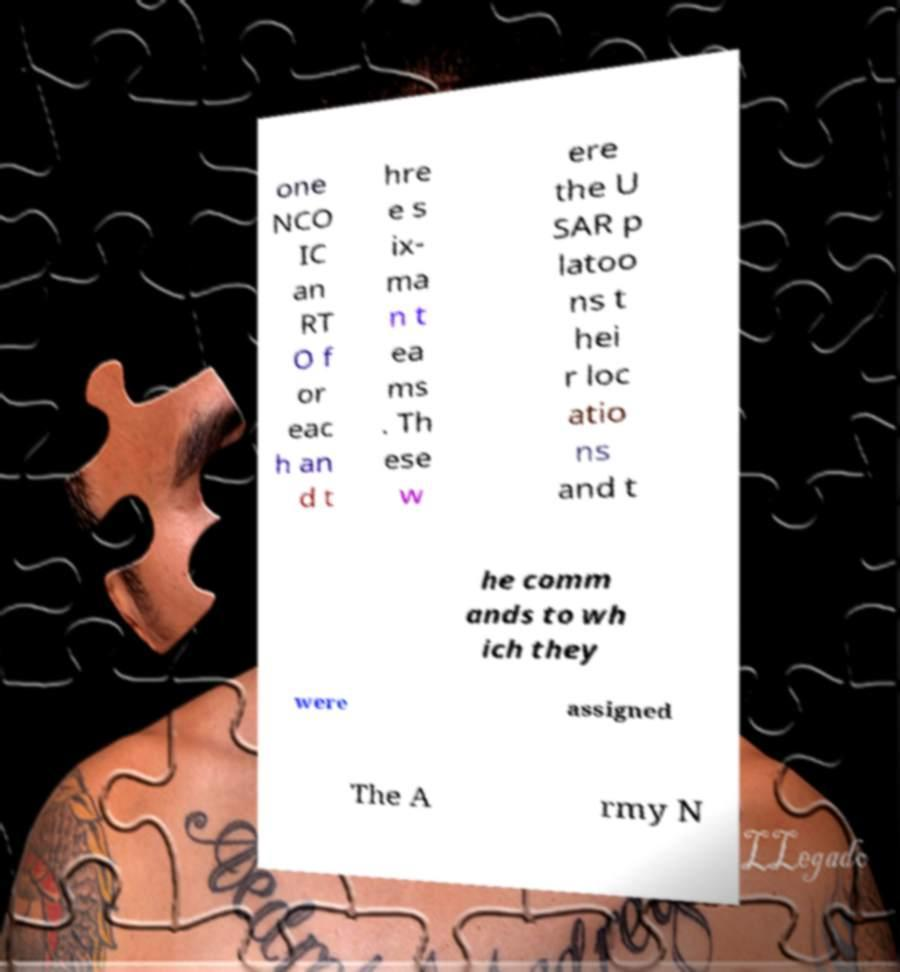I need the written content from this picture converted into text. Can you do that? one NCO IC an RT O f or eac h an d t hre e s ix- ma n t ea ms . Th ese w ere the U SAR p latoo ns t hei r loc atio ns and t he comm ands to wh ich they were assigned The A rmy N 